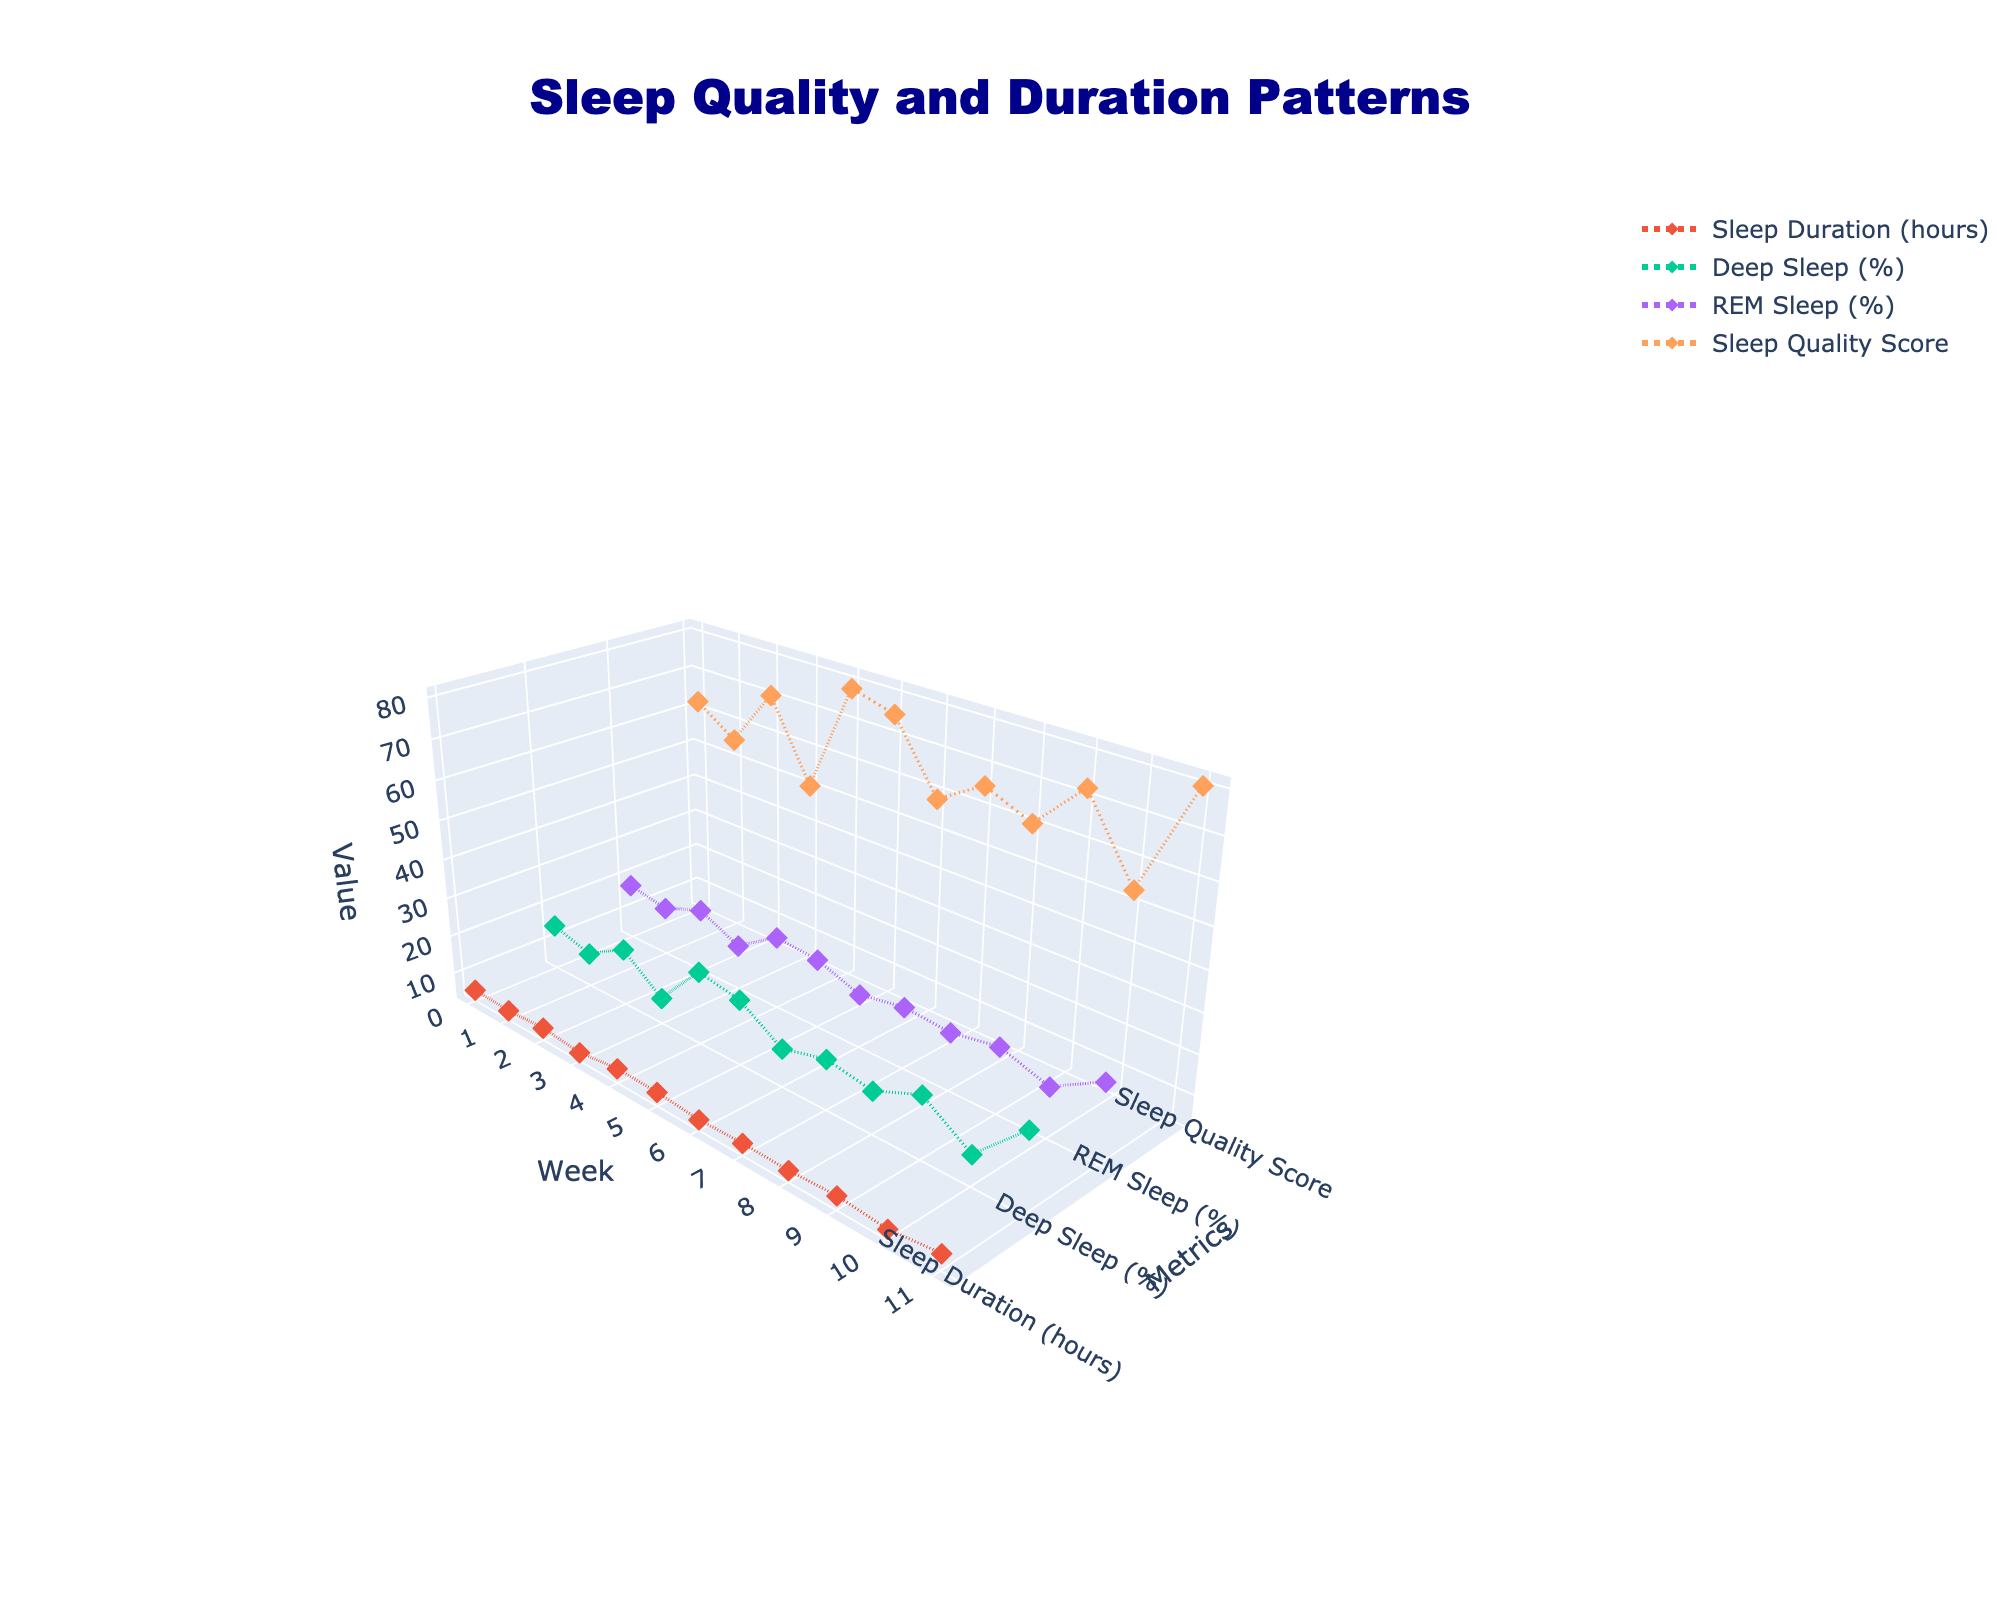What is the title of the figure? The title is typically placed at the top center of the figure. In this case, it reads "Sleep Quality and Duration Patterns".
Answer: Sleep Quality and Duration Patterns What is the x-axis labeled as? The x-axis usually represents the horizontal axis in a 3D plot. In this figure, it is labeled as "Week".
Answer: Week Which week had the highest sleep quality score? By looking at the Sleep Quality Score data and finding the point with the highest position along the z-axis, Week 12 had the highest score of 80.
Answer: Week 12 Between Week 3 and Week 5, which week had a higher percentage of REM Sleep? Week 3 had 20% REM sleep while Week 5 had 22% REM sleep. Comparing these values, Week 5 has a higher percentage.
Answer: Week 5 What is the average sleep duration for all 12 weeks? Sum the sleep duration values for all weeks and divide by the number of weeks: (6.2 + 5.8 + 6.5 + 5.5 + 7.0 + 6.8 + 5.9 + 6.3 + 6.1 + 6.7 + 5.7 + 7.2) / 12 = 6.31 hours.
Answer: 6.31 hours What pattern do you observe in the Deep Sleep percentage over the 12 weeks? Analyzing the Deep Sleep percentage data, there are noticeable fluctuations. The highest is 23% (Week 12), and the lowest is 10% (Week 4). There is a general trend of variability without a clear linear pattern.
Answer: Fluctuations without a clear trend Between which weeks did the Sleep Quality Score increase the most? Calculate the difference between consecutive weeks' Sleep Quality Scores and identify the largest increase: the score increased the most from Week 4 (50) to Week 5 (78).
Answer: Between Week 4 and Week 5 Is there any week where Sleep Duration, Deep Sleep, and REM Sleep all decreased compared to the previous week? By examining the data, Week 7 had decreases in all three metrics compared to Week 6: Sleep Duration (5.9 vs. 6.8), Deep Sleep (13% vs. 20%), REM Sleep (17% vs. 21%).
Answer: Week 7 What is the range of Sleep Quality Scores observed in the 12 weeks? The range is the difference between the maximum and minimum values. The Sleep Quality Scores range from 50 (Week 4) to 80 (Week 12), so the range is 80 - 50 = 30.
Answer: 30 Which week had the lowest percentage of Deep Sleep? The week with the lowest Deep Sleep percentage is Week 4 with 10%.
Answer: Week 4 